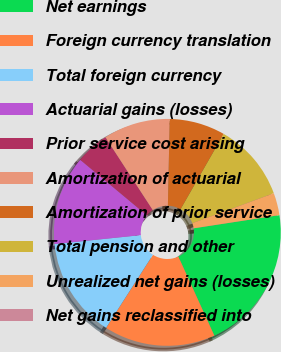Convert chart. <chart><loc_0><loc_0><loc_500><loc_500><pie_chart><fcel>Net earnings<fcel>Foreign currency translation<fcel>Total foreign currency<fcel>Actuarial gains (losses)<fcel>Prior service cost arising<fcel>Amortization of actuarial<fcel>Amortization of prior service<fcel>Total pension and other<fcel>Unrealized net gains (losses)<fcel>Net gains reclassified into<nl><fcel>20.63%<fcel>15.87%<fcel>14.28%<fcel>12.7%<fcel>4.76%<fcel>9.52%<fcel>7.94%<fcel>11.11%<fcel>3.18%<fcel>0.0%<nl></chart> 